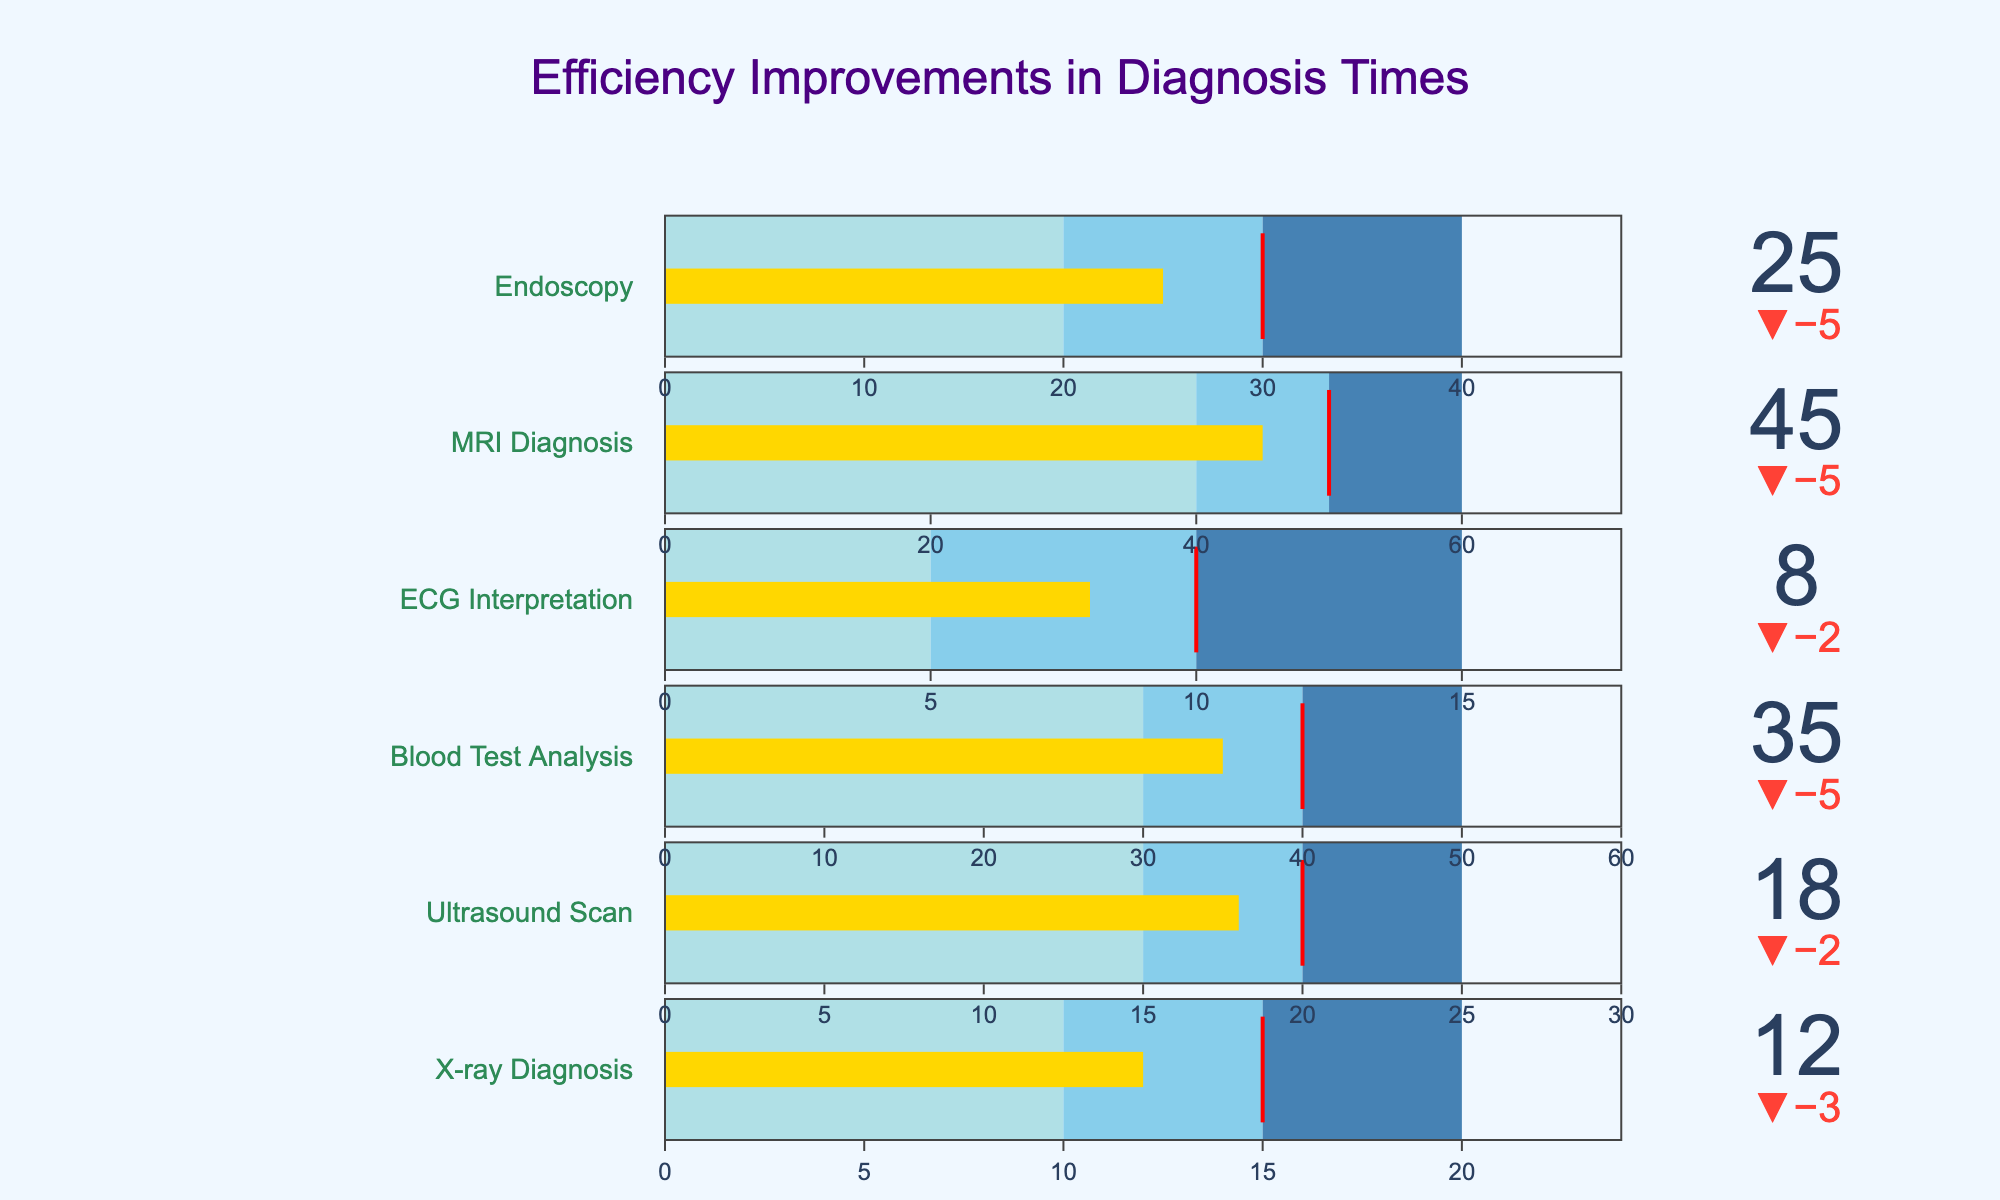What's the title of the figure? The title is typically found at the top of the figure. By looking at the provided image description, the title reads "Efficiency Improvements in Diagnosis Times".
Answer: Efficiency Improvements in Diagnosis Times What is the `Target` value for Ultrasound Scan? Refer to the specific bullet chart for Ultrasound Scan. Under the "gauge" section, there's a label showing the target value. According to the provided data, the target value for Ultrasound Scan is 20.
Answer: 20 Which diagnostic category has the highest efficiency improvement over its target? Compare the "Actual" values to their corresponding "Target" values for each category. The biggest difference indicates the highest efficiency improvement. Here, X-ray Diagnosis shows the most improvement with Actual being 12 and Target 15 (a difference of 3).
Answer: X-ray Diagnosis What are the color codes used to indicate Good, Satisfactory, and Poor performance ranges? Each bullet chart uses different colors to represent performance. According to the code, the "Good" range is light blue, "Satisfactory" range is slightly darker, and "Poor" is even darker blue.
Answer: Light blue, darker blue, darkest blue How effectively has MRI Diagnosis met its target? Compare the "Actual" value of MRI Diagnosis to its "Target" value. The MRI Diagnosis has an Actual value of 45 and a Target value of 50, so it hasn't quite met the target.
Answer: Not met Which diagnostic category has the smallest efficiency improvement over its target? Determine the difference between "Actual" and "Target" values for all categories, then identify the smallest positive difference. The category with the smallest positive difference is Ultrasound Scan (difference of 2).
Answer: Ultrasound Scan What does the red line in the bullet chart represent? In each bullet chart, there is a red line marking a specific threshold. According to the code, this red line represents the "Target" value for each diagnostic category.
Answer: Target value What is the total Target for all diagnostic categories combined? Sum all Target values for each category: 15 + 20 + 40 + 10 + 50 + 30 = 165.
Answer: 165 Did Blood Test Analysis meet or exceed its target? Compare the Actual value (35) with the Target value (40) for Blood Test Analysis. The Actual value is less than the Target value, indicating it did not meet or exceed the target.
Answer: Did not meet What is the average `Actual` value across all diagnostic categories? Calculate the total Actual value by summing each Actual value: 12 + 18 + 35 + 8 + 45 + 25 = 143, then divide by the number of categories (6). 143 / 6 ≈ 23.83.
Answer: 23.83 